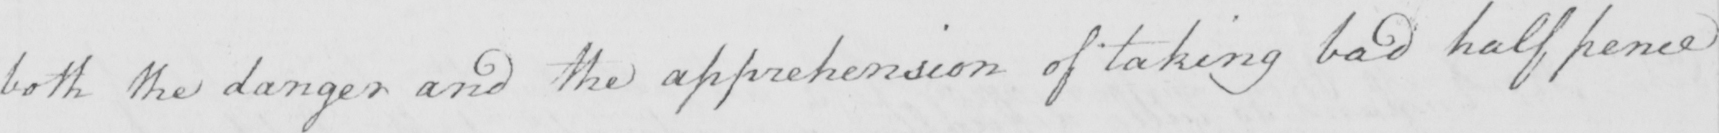What does this handwritten line say? both the danger and the apprehension of taking bad half pence 